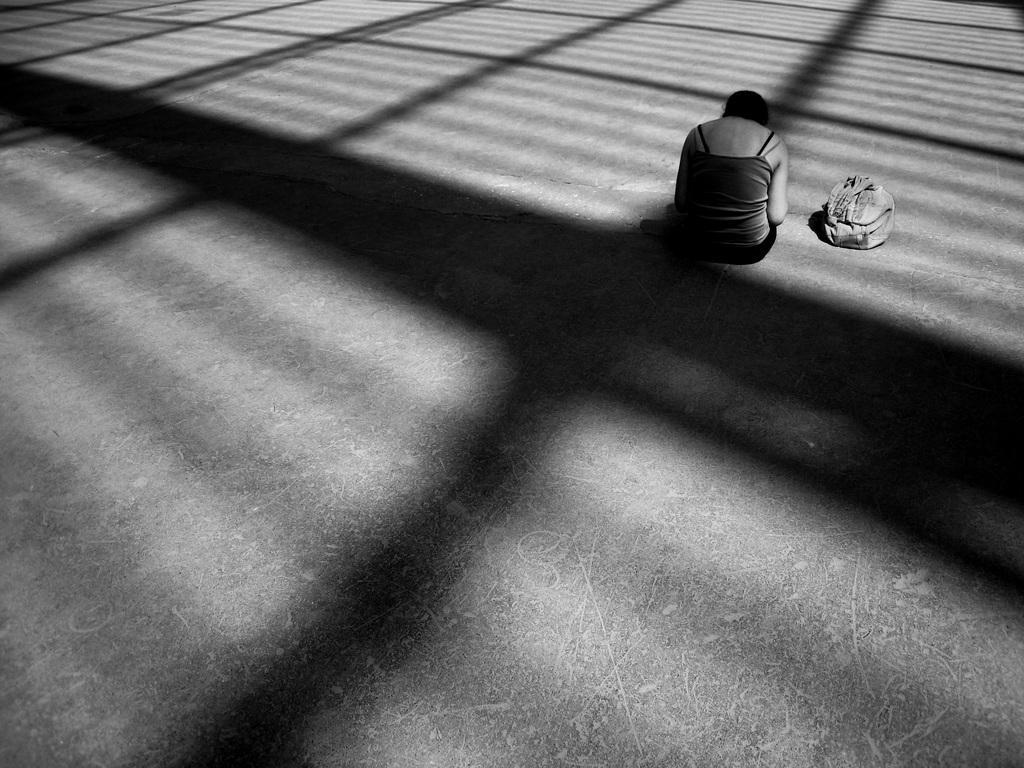Please provide a concise description of this image. It is a black and picture. Here a person is sitting on the surface. Beside her there is a bag. Here we can see shadows of some objects. 